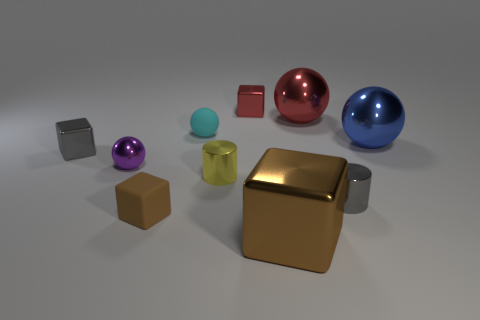There is a shiny object that is both behind the gray shiny block and on the left side of the big brown shiny object; what shape is it?
Your response must be concise. Cube. There is a small gray shiny object left of the cyan rubber ball; what shape is it?
Keep it short and to the point. Cube. What number of balls are right of the purple object and to the left of the rubber block?
Keep it short and to the point. 0. Does the yellow shiny cylinder have the same size as the brown thing to the left of the big brown metal cube?
Provide a short and direct response. Yes. What size is the metal cube that is behind the cyan thing that is in front of the small metal cube behind the cyan object?
Keep it short and to the point. Small. There is a metallic ball behind the blue metal sphere; how big is it?
Offer a terse response. Large. The large red object that is the same material as the tiny purple thing is what shape?
Your answer should be compact. Sphere. Do the large thing that is in front of the small brown rubber thing and the cyan object have the same material?
Offer a terse response. No. What number of other objects are the same material as the big red sphere?
Your answer should be compact. 7. What number of things are either big blocks that are to the left of the gray metal cylinder or cubes that are behind the tiny yellow cylinder?
Offer a terse response. 3. 